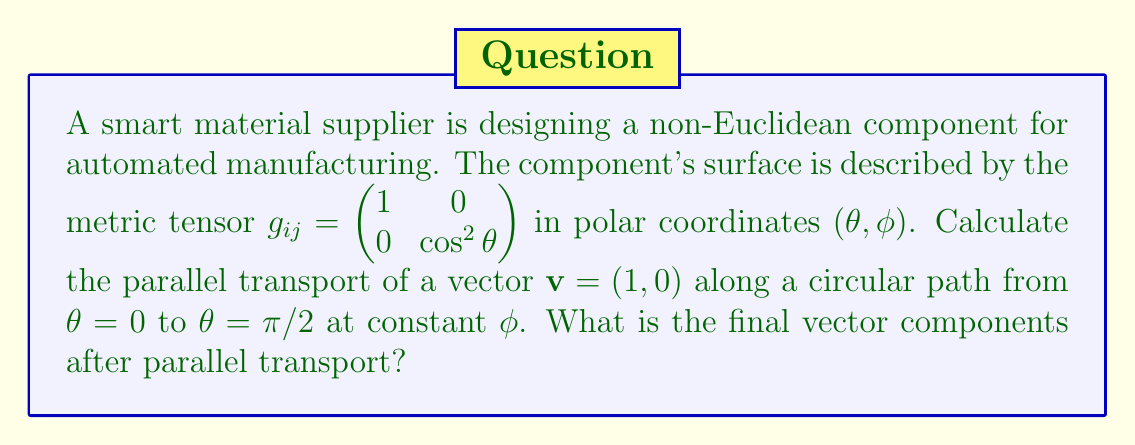Show me your answer to this math problem. To solve this problem, we'll follow these steps:

1) First, we need to calculate the Christoffel symbols for this metric. The non-zero Christoffel symbols are:

   $$\Gamma^\phi_{\theta\phi} = \Gamma^\phi_{\phi\theta} = -\tan\theta$$
   $$\Gamma^\theta_{\phi\phi} = \sin\theta\cos\theta$$

2) The parallel transport equations are:

   $$\frac{dv^\theta}{d\theta} + \Gamma^\theta_{\phi\phi}v^\phi = 0$$
   $$\frac{dv^\phi}{d\theta} + \Gamma^\phi_{\theta\phi}v^\phi = 0$$

3) Given $\mathbf{v} = (1, 0)$ initially, we have $v^\theta = 1$ and $v^\phi = 0$ at $\theta = 0$.

4) The second equation becomes trivial: $\frac{dv^\phi}{d\theta} = 0$, so $v^\phi$ remains 0 throughout the transport.

5) The first equation becomes:

   $$\frac{dv^\theta}{d\theta} = 0$$

   This means $v^\theta$ also remains constant.

6) Therefore, the vector components don't change during parallel transport along this path.

7) The final vector at $\theta = \pi/2$ is still $(1, 0)$ in the $(\theta, \phi)$ coordinate system.

8) However, we need to express this in terms of the original orthonormal basis. At $\theta = \pi/2$, the $\phi$ direction is scaled by $\cos(\pi/2) = 0$, so the final vector in the orthonormal basis is $(1, 0)$.
Answer: $(1, 0)$ 